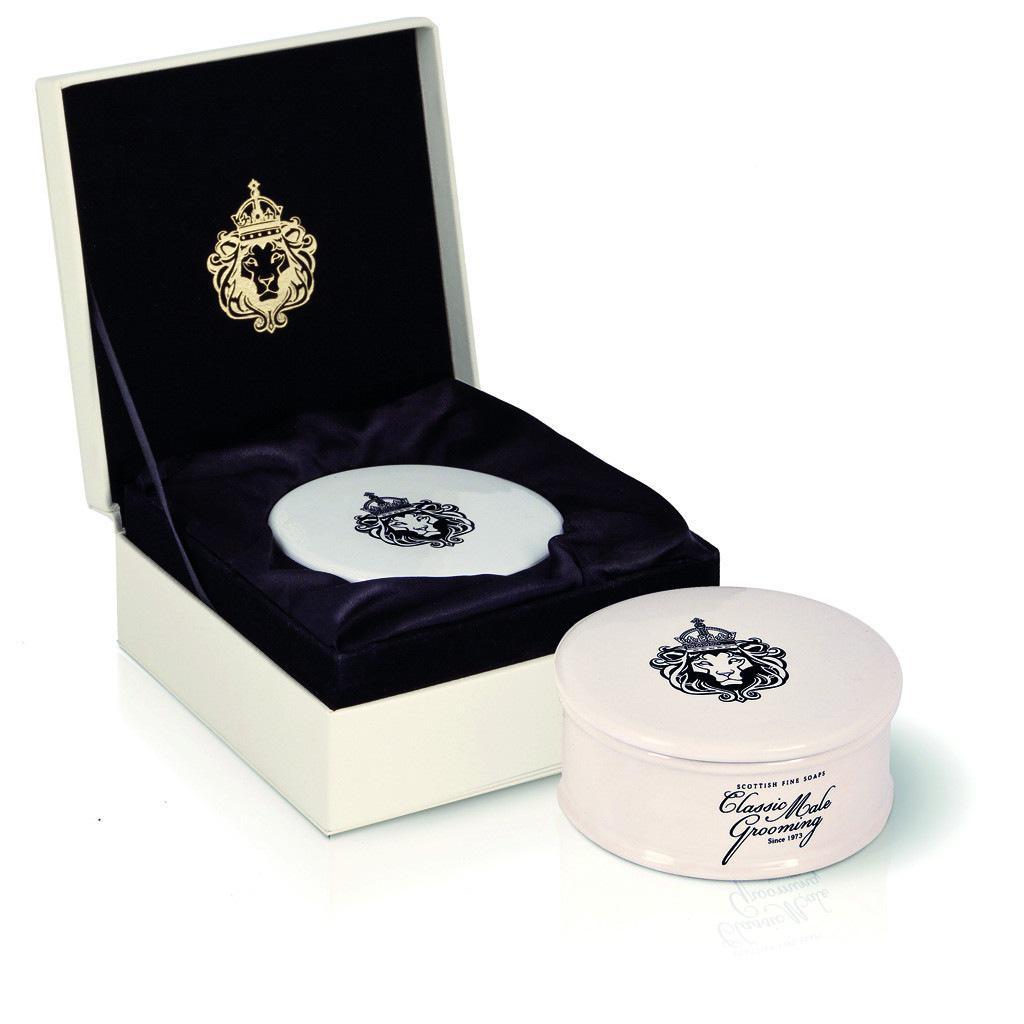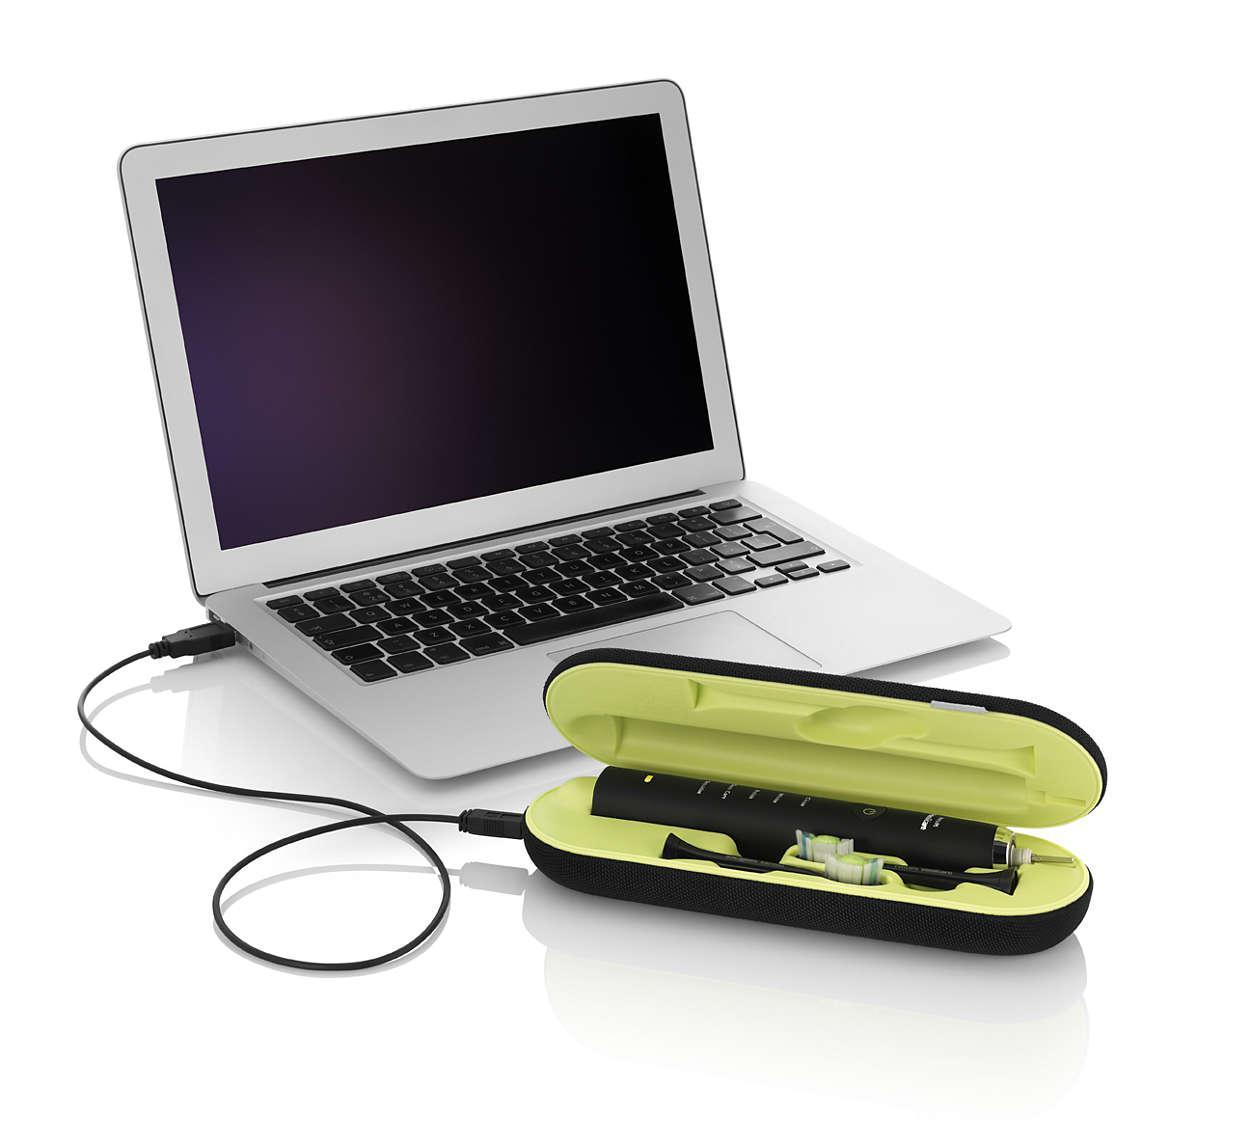The first image is the image on the left, the second image is the image on the right. For the images displayed, is the sentence "There is one cord visible." factually correct? Answer yes or no. Yes. The first image is the image on the left, the second image is the image on the right. For the images displayed, is the sentence "In the left image, there's a laptop by itself." factually correct? Answer yes or no. No. 